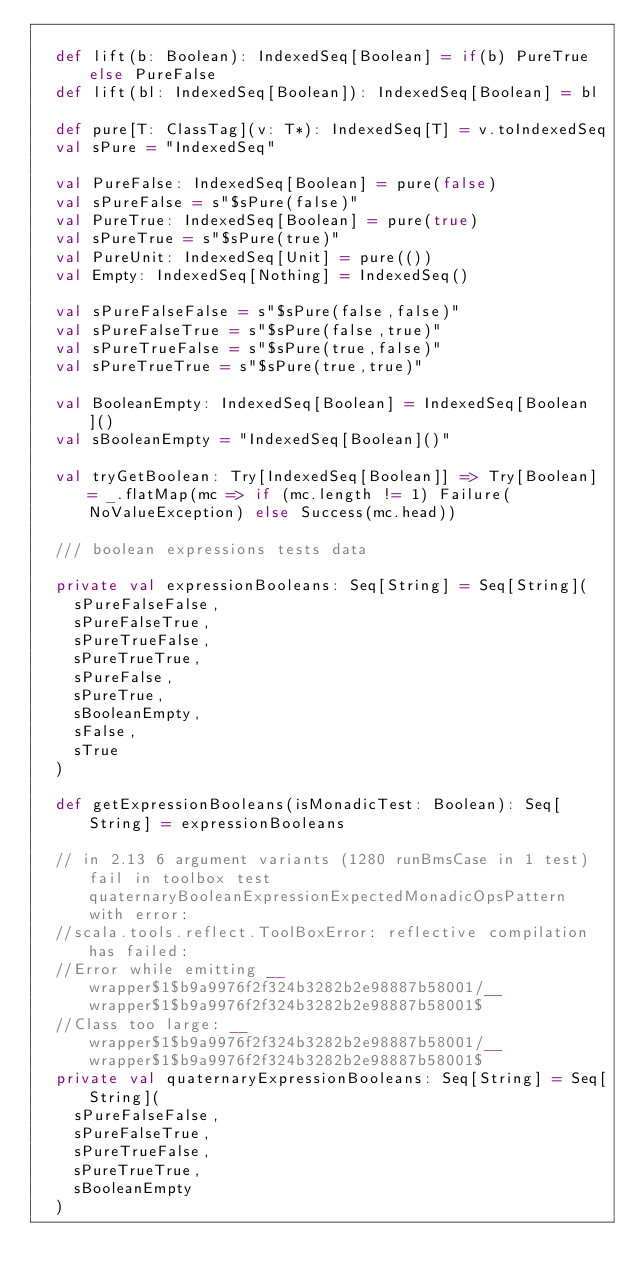Convert code to text. <code><loc_0><loc_0><loc_500><loc_500><_Scala_>
  def lift(b: Boolean): IndexedSeq[Boolean] = if(b) PureTrue else PureFalse
  def lift(bl: IndexedSeq[Boolean]): IndexedSeq[Boolean] = bl

  def pure[T: ClassTag](v: T*): IndexedSeq[T] = v.toIndexedSeq
  val sPure = "IndexedSeq"

  val PureFalse: IndexedSeq[Boolean] = pure(false)
  val sPureFalse = s"$sPure(false)"
  val PureTrue: IndexedSeq[Boolean] = pure(true)
  val sPureTrue = s"$sPure(true)"
  val PureUnit: IndexedSeq[Unit] = pure(())
  val Empty: IndexedSeq[Nothing] = IndexedSeq()

  val sPureFalseFalse = s"$sPure(false,false)"
  val sPureFalseTrue = s"$sPure(false,true)"
  val sPureTrueFalse = s"$sPure(true,false)"
  val sPureTrueTrue = s"$sPure(true,true)"

  val BooleanEmpty: IndexedSeq[Boolean] = IndexedSeq[Boolean]()
  val sBooleanEmpty = "IndexedSeq[Boolean]()"

  val tryGetBoolean: Try[IndexedSeq[Boolean]] => Try[Boolean] = _.flatMap(mc => if (mc.length != 1) Failure(NoValueException) else Success(mc.head))

  /// boolean expressions tests data

  private val expressionBooleans: Seq[String] = Seq[String](
    sPureFalseFalse,
    sPureFalseTrue,
    sPureTrueFalse,
    sPureTrueTrue,
    sPureFalse,
    sPureTrue,
    sBooleanEmpty,
    sFalse,
    sTrue
  )

  def getExpressionBooleans(isMonadicTest: Boolean): Seq[String] = expressionBooleans

  // in 2.13 6 argument variants (1280 runBmsCase in 1 test) fail in toolbox test quaternaryBooleanExpressionExpectedMonadicOpsPattern with error:
  //scala.tools.reflect.ToolBoxError: reflective compilation has failed:
  //Error while emitting __wrapper$1$b9a9976f2f324b3282b2e98887b58001/__wrapper$1$b9a9976f2f324b3282b2e98887b58001$
  //Class too large: __wrapper$1$b9a9976f2f324b3282b2e98887b58001/__wrapper$1$b9a9976f2f324b3282b2e98887b58001$
  private val quaternaryExpressionBooleans: Seq[String] = Seq[String](
    sPureFalseFalse,
    sPureFalseTrue,
    sPureTrueFalse,
    sPureTrueTrue,
    sBooleanEmpty
  )</code> 